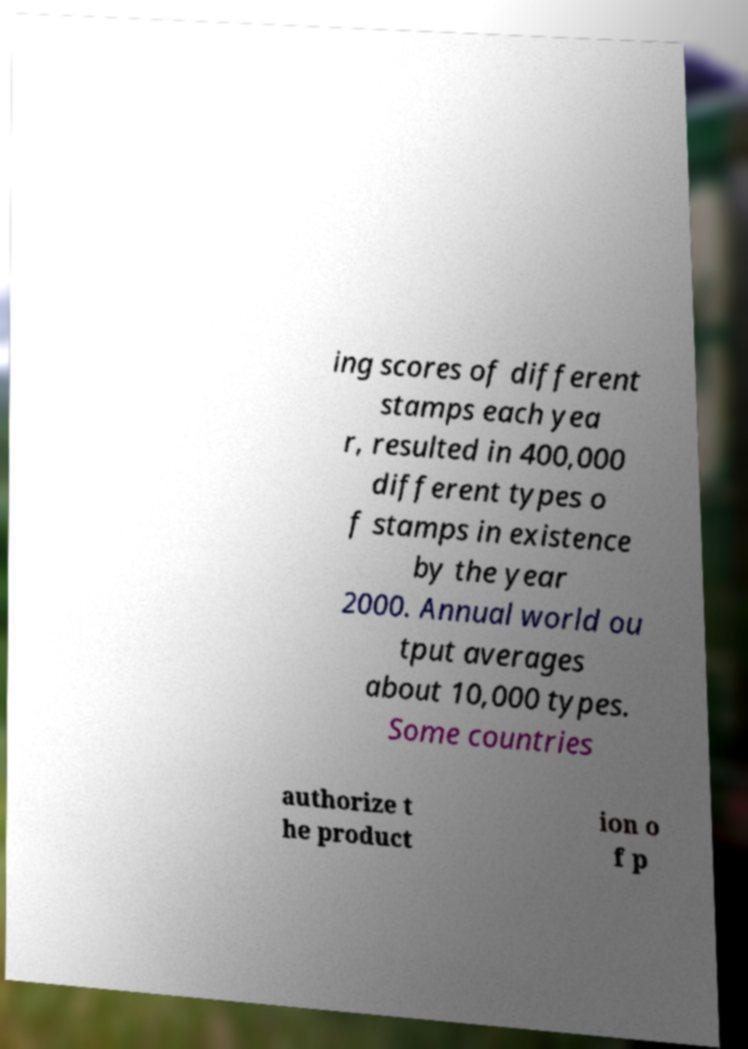Can you accurately transcribe the text from the provided image for me? ing scores of different stamps each yea r, resulted in 400,000 different types o f stamps in existence by the year 2000. Annual world ou tput averages about 10,000 types. Some countries authorize t he product ion o f p 